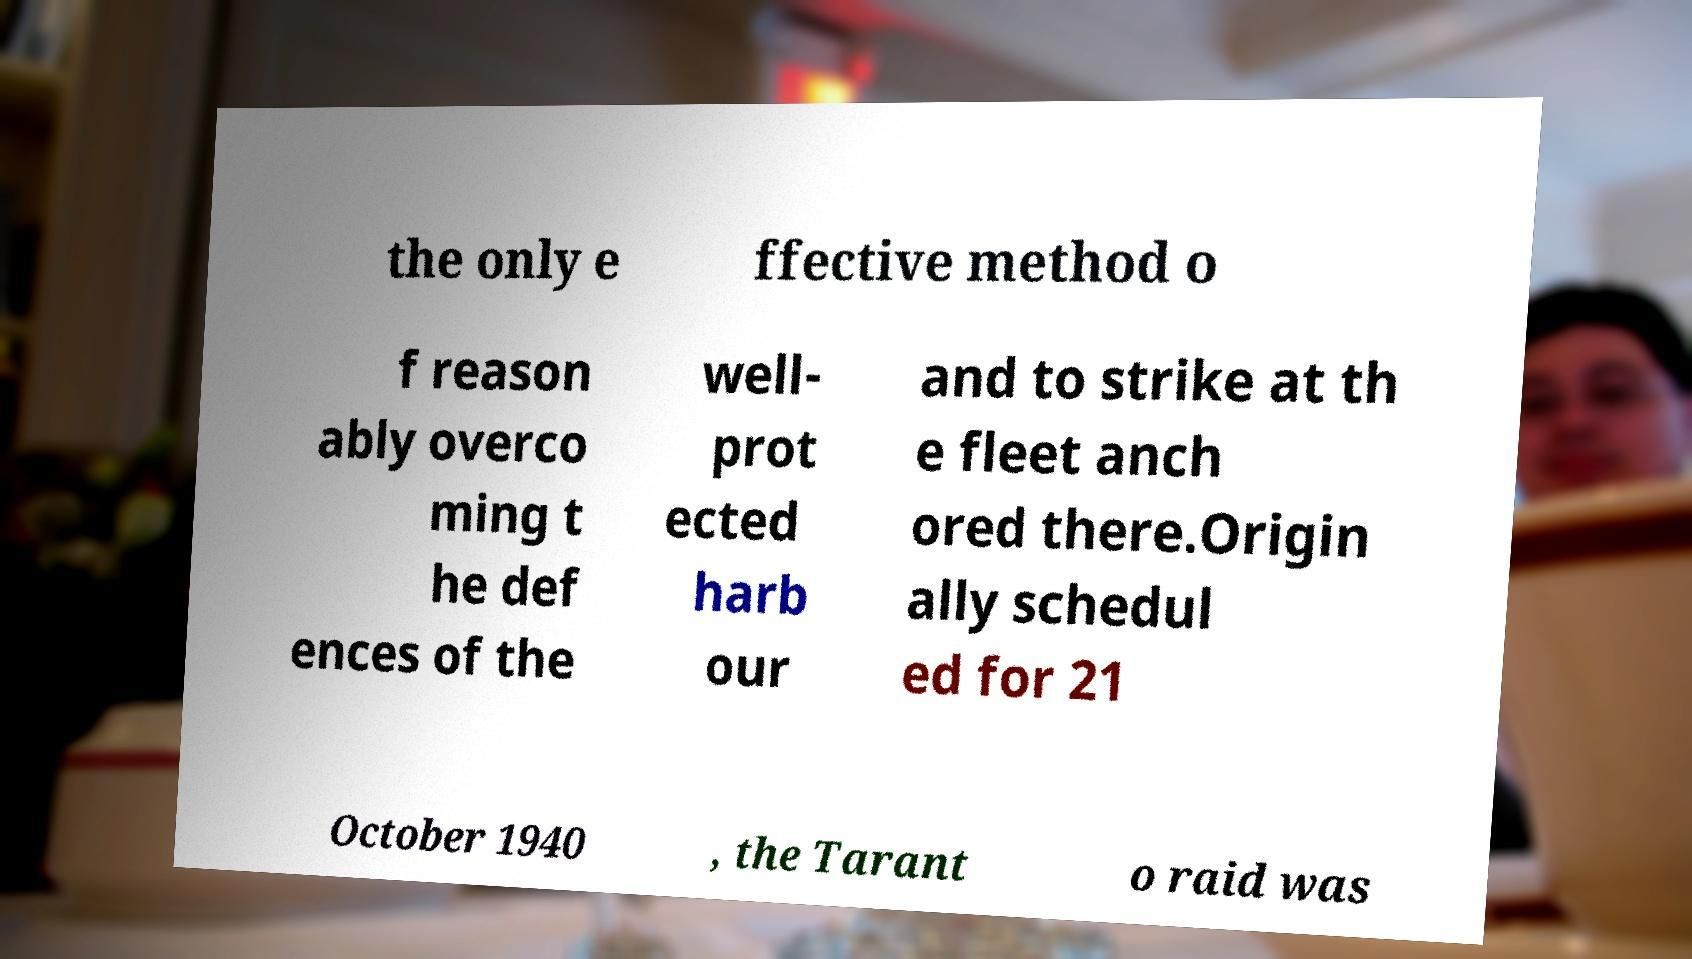Please read and relay the text visible in this image. What does it say? the only e ffective method o f reason ably overco ming t he def ences of the well- prot ected harb our and to strike at th e fleet anch ored there.Origin ally schedul ed for 21 October 1940 , the Tarant o raid was 